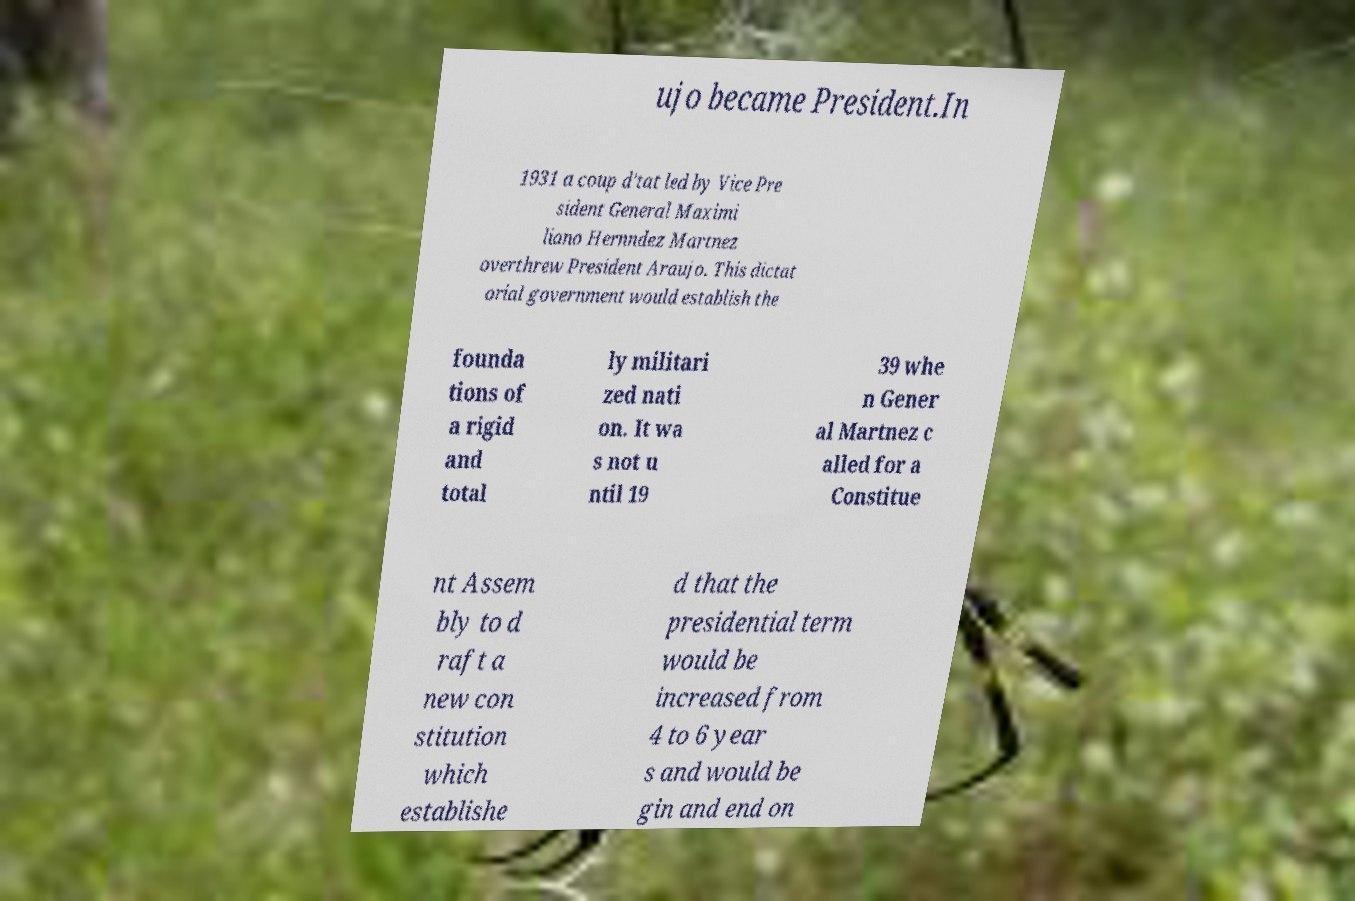Please read and relay the text visible in this image. What does it say? ujo became President.In 1931 a coup d'tat led by Vice Pre sident General Maximi liano Hernndez Martnez overthrew President Araujo. This dictat orial government would establish the founda tions of a rigid and total ly militari zed nati on. It wa s not u ntil 19 39 whe n Gener al Martnez c alled for a Constitue nt Assem bly to d raft a new con stitution which establishe d that the presidential term would be increased from 4 to 6 year s and would be gin and end on 